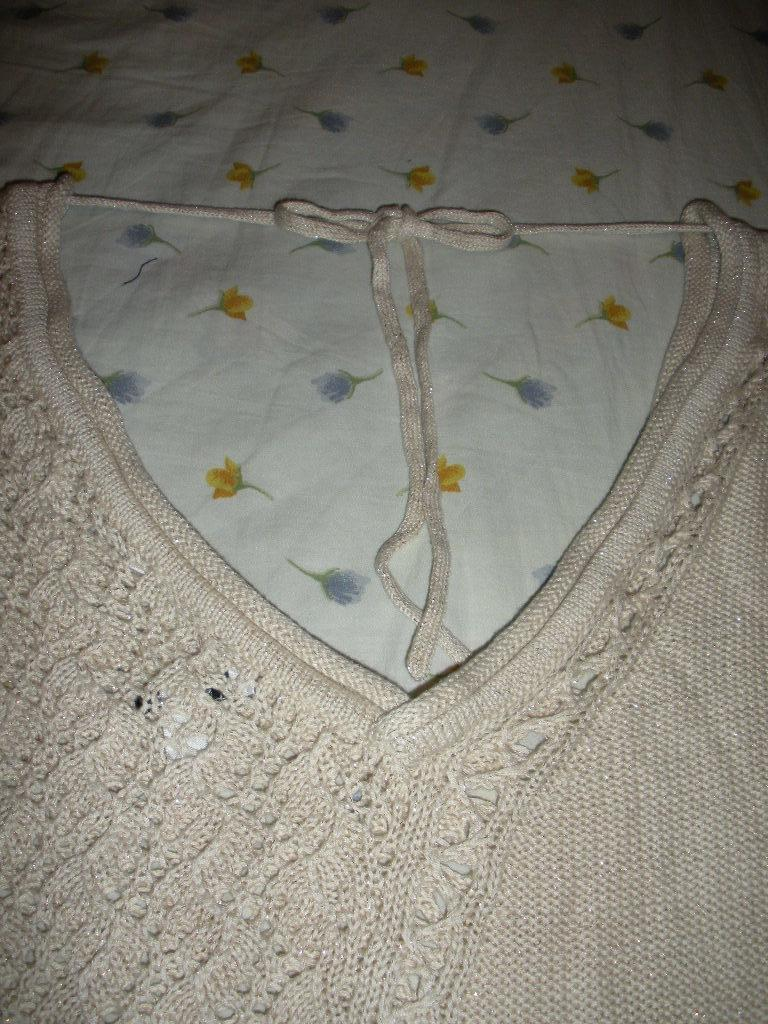What type of material is featured in the image? There is woolen cloth in the image. What can be observed on the woolen cloth? The woolen cloth has threads on it. What other type of cloth is present in the image? There is a white cloth in the image. What type of relation does the woolen cloth have with the tail in the image? There is no tail present in the image, so no relation can be established between the woolen cloth and a tail. 